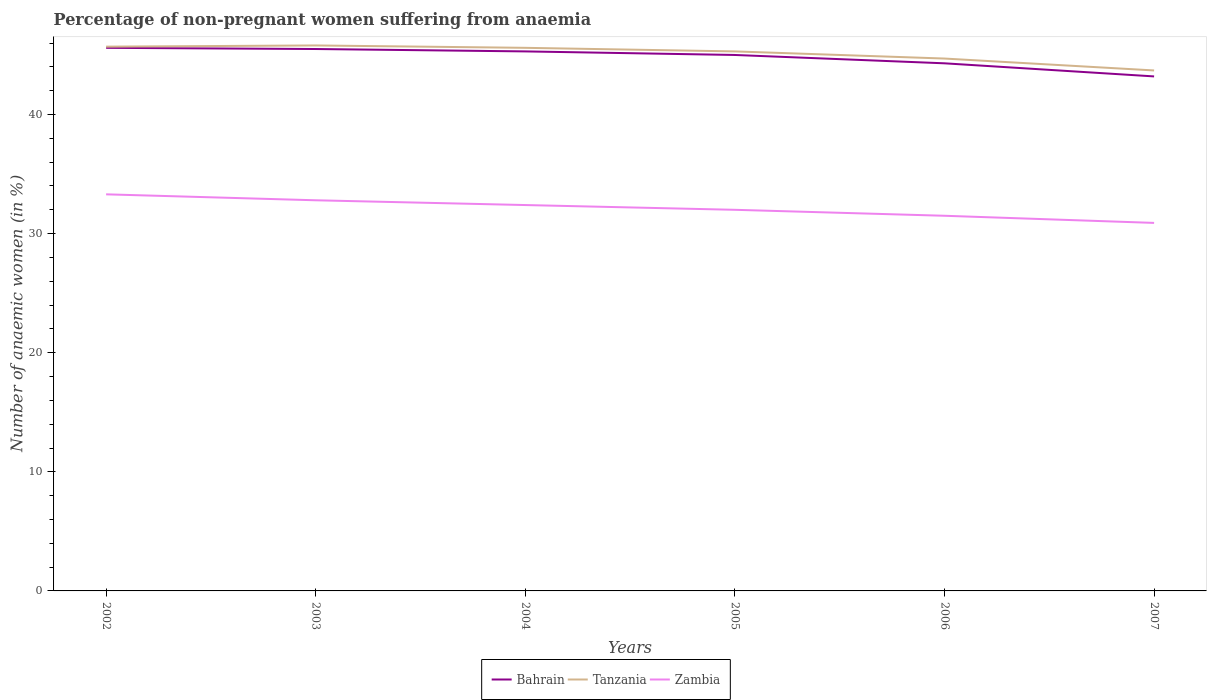How many different coloured lines are there?
Offer a terse response. 3. Does the line corresponding to Tanzania intersect with the line corresponding to Zambia?
Your response must be concise. No. Across all years, what is the maximum percentage of non-pregnant women suffering from anaemia in Bahrain?
Your response must be concise. 43.2. In which year was the percentage of non-pregnant women suffering from anaemia in Bahrain maximum?
Ensure brevity in your answer.  2007. What is the difference between the highest and the second highest percentage of non-pregnant women suffering from anaemia in Tanzania?
Your answer should be compact. 2.1. Is the percentage of non-pregnant women suffering from anaemia in Tanzania strictly greater than the percentage of non-pregnant women suffering from anaemia in Bahrain over the years?
Provide a succinct answer. No. Does the graph contain grids?
Make the answer very short. No. How are the legend labels stacked?
Ensure brevity in your answer.  Horizontal. What is the title of the graph?
Ensure brevity in your answer.  Percentage of non-pregnant women suffering from anaemia. What is the label or title of the X-axis?
Your answer should be very brief. Years. What is the label or title of the Y-axis?
Your answer should be compact. Number of anaemic women (in %). What is the Number of anaemic women (in %) of Bahrain in 2002?
Provide a succinct answer. 45.6. What is the Number of anaemic women (in %) in Tanzania in 2002?
Offer a very short reply. 45.7. What is the Number of anaemic women (in %) in Zambia in 2002?
Provide a short and direct response. 33.3. What is the Number of anaemic women (in %) of Bahrain in 2003?
Keep it short and to the point. 45.5. What is the Number of anaemic women (in %) of Tanzania in 2003?
Provide a succinct answer. 45.8. What is the Number of anaemic women (in %) of Zambia in 2003?
Your response must be concise. 32.8. What is the Number of anaemic women (in %) in Bahrain in 2004?
Your response must be concise. 45.3. What is the Number of anaemic women (in %) of Tanzania in 2004?
Keep it short and to the point. 45.6. What is the Number of anaemic women (in %) of Zambia in 2004?
Your answer should be very brief. 32.4. What is the Number of anaemic women (in %) of Bahrain in 2005?
Your response must be concise. 45. What is the Number of anaemic women (in %) of Tanzania in 2005?
Make the answer very short. 45.3. What is the Number of anaemic women (in %) in Bahrain in 2006?
Your response must be concise. 44.3. What is the Number of anaemic women (in %) of Tanzania in 2006?
Ensure brevity in your answer.  44.7. What is the Number of anaemic women (in %) of Zambia in 2006?
Your answer should be very brief. 31.5. What is the Number of anaemic women (in %) in Bahrain in 2007?
Give a very brief answer. 43.2. What is the Number of anaemic women (in %) in Tanzania in 2007?
Offer a terse response. 43.7. What is the Number of anaemic women (in %) in Zambia in 2007?
Make the answer very short. 30.9. Across all years, what is the maximum Number of anaemic women (in %) of Bahrain?
Keep it short and to the point. 45.6. Across all years, what is the maximum Number of anaemic women (in %) in Tanzania?
Your answer should be very brief. 45.8. Across all years, what is the maximum Number of anaemic women (in %) in Zambia?
Give a very brief answer. 33.3. Across all years, what is the minimum Number of anaemic women (in %) in Bahrain?
Your answer should be very brief. 43.2. Across all years, what is the minimum Number of anaemic women (in %) of Tanzania?
Your answer should be very brief. 43.7. Across all years, what is the minimum Number of anaemic women (in %) in Zambia?
Provide a succinct answer. 30.9. What is the total Number of anaemic women (in %) of Bahrain in the graph?
Keep it short and to the point. 268.9. What is the total Number of anaemic women (in %) of Tanzania in the graph?
Make the answer very short. 270.8. What is the total Number of anaemic women (in %) of Zambia in the graph?
Your response must be concise. 192.9. What is the difference between the Number of anaemic women (in %) in Zambia in 2002 and that in 2003?
Your answer should be very brief. 0.5. What is the difference between the Number of anaemic women (in %) in Bahrain in 2002 and that in 2004?
Offer a terse response. 0.3. What is the difference between the Number of anaemic women (in %) in Tanzania in 2002 and that in 2004?
Provide a short and direct response. 0.1. What is the difference between the Number of anaemic women (in %) of Zambia in 2002 and that in 2004?
Offer a terse response. 0.9. What is the difference between the Number of anaemic women (in %) of Bahrain in 2002 and that in 2005?
Your answer should be very brief. 0.6. What is the difference between the Number of anaemic women (in %) of Tanzania in 2002 and that in 2005?
Your answer should be very brief. 0.4. What is the difference between the Number of anaemic women (in %) in Bahrain in 2002 and that in 2007?
Provide a succinct answer. 2.4. What is the difference between the Number of anaemic women (in %) of Tanzania in 2002 and that in 2007?
Make the answer very short. 2. What is the difference between the Number of anaemic women (in %) of Bahrain in 2003 and that in 2004?
Make the answer very short. 0.2. What is the difference between the Number of anaemic women (in %) in Tanzania in 2003 and that in 2004?
Offer a terse response. 0.2. What is the difference between the Number of anaemic women (in %) of Zambia in 2003 and that in 2006?
Offer a terse response. 1.3. What is the difference between the Number of anaemic women (in %) in Tanzania in 2003 and that in 2007?
Your answer should be very brief. 2.1. What is the difference between the Number of anaemic women (in %) of Zambia in 2004 and that in 2005?
Keep it short and to the point. 0.4. What is the difference between the Number of anaemic women (in %) in Bahrain in 2004 and that in 2006?
Provide a succinct answer. 1. What is the difference between the Number of anaemic women (in %) of Tanzania in 2004 and that in 2006?
Provide a short and direct response. 0.9. What is the difference between the Number of anaemic women (in %) of Zambia in 2004 and that in 2006?
Your response must be concise. 0.9. What is the difference between the Number of anaemic women (in %) of Bahrain in 2004 and that in 2007?
Give a very brief answer. 2.1. What is the difference between the Number of anaemic women (in %) in Tanzania in 2004 and that in 2007?
Offer a terse response. 1.9. What is the difference between the Number of anaemic women (in %) in Bahrain in 2005 and that in 2006?
Provide a short and direct response. 0.7. What is the difference between the Number of anaemic women (in %) of Zambia in 2005 and that in 2006?
Make the answer very short. 0.5. What is the difference between the Number of anaemic women (in %) of Bahrain in 2002 and the Number of anaemic women (in %) of Tanzania in 2003?
Give a very brief answer. -0.2. What is the difference between the Number of anaemic women (in %) in Tanzania in 2002 and the Number of anaemic women (in %) in Zambia in 2003?
Give a very brief answer. 12.9. What is the difference between the Number of anaemic women (in %) in Bahrain in 2002 and the Number of anaemic women (in %) in Zambia in 2004?
Make the answer very short. 13.2. What is the difference between the Number of anaemic women (in %) of Bahrain in 2002 and the Number of anaemic women (in %) of Tanzania in 2005?
Provide a succinct answer. 0.3. What is the difference between the Number of anaemic women (in %) of Tanzania in 2002 and the Number of anaemic women (in %) of Zambia in 2005?
Your answer should be very brief. 13.7. What is the difference between the Number of anaemic women (in %) of Bahrain in 2002 and the Number of anaemic women (in %) of Tanzania in 2006?
Provide a short and direct response. 0.9. What is the difference between the Number of anaemic women (in %) of Bahrain in 2002 and the Number of anaemic women (in %) of Tanzania in 2007?
Give a very brief answer. 1.9. What is the difference between the Number of anaemic women (in %) of Tanzania in 2002 and the Number of anaemic women (in %) of Zambia in 2007?
Give a very brief answer. 14.8. What is the difference between the Number of anaemic women (in %) in Bahrain in 2003 and the Number of anaemic women (in %) in Tanzania in 2004?
Offer a terse response. -0.1. What is the difference between the Number of anaemic women (in %) in Bahrain in 2003 and the Number of anaemic women (in %) in Zambia in 2004?
Your answer should be very brief. 13.1. What is the difference between the Number of anaemic women (in %) of Bahrain in 2003 and the Number of anaemic women (in %) of Zambia in 2005?
Offer a terse response. 13.5. What is the difference between the Number of anaemic women (in %) of Tanzania in 2003 and the Number of anaemic women (in %) of Zambia in 2005?
Offer a very short reply. 13.8. What is the difference between the Number of anaemic women (in %) of Bahrain in 2003 and the Number of anaemic women (in %) of Tanzania in 2006?
Give a very brief answer. 0.8. What is the difference between the Number of anaemic women (in %) of Tanzania in 2003 and the Number of anaemic women (in %) of Zambia in 2006?
Make the answer very short. 14.3. What is the difference between the Number of anaemic women (in %) in Tanzania in 2003 and the Number of anaemic women (in %) in Zambia in 2007?
Offer a very short reply. 14.9. What is the difference between the Number of anaemic women (in %) of Bahrain in 2004 and the Number of anaemic women (in %) of Zambia in 2005?
Offer a very short reply. 13.3. What is the difference between the Number of anaemic women (in %) in Bahrain in 2004 and the Number of anaemic women (in %) in Tanzania in 2007?
Offer a very short reply. 1.6. What is the difference between the Number of anaemic women (in %) in Bahrain in 2004 and the Number of anaemic women (in %) in Zambia in 2007?
Ensure brevity in your answer.  14.4. What is the difference between the Number of anaemic women (in %) in Tanzania in 2004 and the Number of anaemic women (in %) in Zambia in 2007?
Make the answer very short. 14.7. What is the difference between the Number of anaemic women (in %) in Bahrain in 2005 and the Number of anaemic women (in %) in Zambia in 2006?
Offer a terse response. 13.5. What is the difference between the Number of anaemic women (in %) in Bahrain in 2005 and the Number of anaemic women (in %) in Tanzania in 2007?
Make the answer very short. 1.3. What is the difference between the Number of anaemic women (in %) of Bahrain in 2005 and the Number of anaemic women (in %) of Zambia in 2007?
Your response must be concise. 14.1. What is the difference between the Number of anaemic women (in %) of Tanzania in 2005 and the Number of anaemic women (in %) of Zambia in 2007?
Your answer should be compact. 14.4. What is the difference between the Number of anaemic women (in %) of Bahrain in 2006 and the Number of anaemic women (in %) of Tanzania in 2007?
Offer a very short reply. 0.6. What is the difference between the Number of anaemic women (in %) of Tanzania in 2006 and the Number of anaemic women (in %) of Zambia in 2007?
Give a very brief answer. 13.8. What is the average Number of anaemic women (in %) of Bahrain per year?
Provide a succinct answer. 44.82. What is the average Number of anaemic women (in %) in Tanzania per year?
Your answer should be compact. 45.13. What is the average Number of anaemic women (in %) of Zambia per year?
Your response must be concise. 32.15. In the year 2002, what is the difference between the Number of anaemic women (in %) in Bahrain and Number of anaemic women (in %) in Tanzania?
Your response must be concise. -0.1. In the year 2003, what is the difference between the Number of anaemic women (in %) in Bahrain and Number of anaemic women (in %) in Tanzania?
Keep it short and to the point. -0.3. In the year 2003, what is the difference between the Number of anaemic women (in %) of Tanzania and Number of anaemic women (in %) of Zambia?
Ensure brevity in your answer.  13. In the year 2004, what is the difference between the Number of anaemic women (in %) of Bahrain and Number of anaemic women (in %) of Tanzania?
Offer a very short reply. -0.3. In the year 2004, what is the difference between the Number of anaemic women (in %) in Tanzania and Number of anaemic women (in %) in Zambia?
Offer a very short reply. 13.2. In the year 2005, what is the difference between the Number of anaemic women (in %) in Bahrain and Number of anaemic women (in %) in Zambia?
Provide a short and direct response. 13. In the year 2006, what is the difference between the Number of anaemic women (in %) of Bahrain and Number of anaemic women (in %) of Tanzania?
Your answer should be very brief. -0.4. In the year 2007, what is the difference between the Number of anaemic women (in %) of Tanzania and Number of anaemic women (in %) of Zambia?
Your answer should be compact. 12.8. What is the ratio of the Number of anaemic women (in %) of Zambia in 2002 to that in 2003?
Your response must be concise. 1.02. What is the ratio of the Number of anaemic women (in %) in Bahrain in 2002 to that in 2004?
Give a very brief answer. 1.01. What is the ratio of the Number of anaemic women (in %) of Zambia in 2002 to that in 2004?
Ensure brevity in your answer.  1.03. What is the ratio of the Number of anaemic women (in %) of Bahrain in 2002 to that in 2005?
Your answer should be compact. 1.01. What is the ratio of the Number of anaemic women (in %) of Tanzania in 2002 to that in 2005?
Give a very brief answer. 1.01. What is the ratio of the Number of anaemic women (in %) of Zambia in 2002 to that in 2005?
Give a very brief answer. 1.04. What is the ratio of the Number of anaemic women (in %) of Bahrain in 2002 to that in 2006?
Your answer should be very brief. 1.03. What is the ratio of the Number of anaemic women (in %) of Tanzania in 2002 to that in 2006?
Make the answer very short. 1.02. What is the ratio of the Number of anaemic women (in %) of Zambia in 2002 to that in 2006?
Provide a short and direct response. 1.06. What is the ratio of the Number of anaemic women (in %) of Bahrain in 2002 to that in 2007?
Offer a terse response. 1.06. What is the ratio of the Number of anaemic women (in %) of Tanzania in 2002 to that in 2007?
Offer a terse response. 1.05. What is the ratio of the Number of anaemic women (in %) in Zambia in 2002 to that in 2007?
Your answer should be compact. 1.08. What is the ratio of the Number of anaemic women (in %) in Zambia in 2003 to that in 2004?
Give a very brief answer. 1.01. What is the ratio of the Number of anaemic women (in %) in Bahrain in 2003 to that in 2005?
Your answer should be compact. 1.01. What is the ratio of the Number of anaemic women (in %) in Tanzania in 2003 to that in 2005?
Offer a terse response. 1.01. What is the ratio of the Number of anaemic women (in %) in Bahrain in 2003 to that in 2006?
Provide a succinct answer. 1.03. What is the ratio of the Number of anaemic women (in %) of Tanzania in 2003 to that in 2006?
Keep it short and to the point. 1.02. What is the ratio of the Number of anaemic women (in %) in Zambia in 2003 to that in 2006?
Provide a short and direct response. 1.04. What is the ratio of the Number of anaemic women (in %) in Bahrain in 2003 to that in 2007?
Your response must be concise. 1.05. What is the ratio of the Number of anaemic women (in %) in Tanzania in 2003 to that in 2007?
Your response must be concise. 1.05. What is the ratio of the Number of anaemic women (in %) of Zambia in 2003 to that in 2007?
Your response must be concise. 1.06. What is the ratio of the Number of anaemic women (in %) in Bahrain in 2004 to that in 2005?
Make the answer very short. 1.01. What is the ratio of the Number of anaemic women (in %) in Tanzania in 2004 to that in 2005?
Your answer should be very brief. 1.01. What is the ratio of the Number of anaemic women (in %) in Zambia in 2004 to that in 2005?
Give a very brief answer. 1.01. What is the ratio of the Number of anaemic women (in %) of Bahrain in 2004 to that in 2006?
Offer a very short reply. 1.02. What is the ratio of the Number of anaemic women (in %) in Tanzania in 2004 to that in 2006?
Make the answer very short. 1.02. What is the ratio of the Number of anaemic women (in %) of Zambia in 2004 to that in 2006?
Keep it short and to the point. 1.03. What is the ratio of the Number of anaemic women (in %) of Bahrain in 2004 to that in 2007?
Your answer should be very brief. 1.05. What is the ratio of the Number of anaemic women (in %) of Tanzania in 2004 to that in 2007?
Give a very brief answer. 1.04. What is the ratio of the Number of anaemic women (in %) in Zambia in 2004 to that in 2007?
Your answer should be very brief. 1.05. What is the ratio of the Number of anaemic women (in %) of Bahrain in 2005 to that in 2006?
Provide a short and direct response. 1.02. What is the ratio of the Number of anaemic women (in %) of Tanzania in 2005 to that in 2006?
Your answer should be compact. 1.01. What is the ratio of the Number of anaemic women (in %) in Zambia in 2005 to that in 2006?
Keep it short and to the point. 1.02. What is the ratio of the Number of anaemic women (in %) of Bahrain in 2005 to that in 2007?
Your answer should be compact. 1.04. What is the ratio of the Number of anaemic women (in %) in Tanzania in 2005 to that in 2007?
Your answer should be very brief. 1.04. What is the ratio of the Number of anaemic women (in %) of Zambia in 2005 to that in 2007?
Offer a terse response. 1.04. What is the ratio of the Number of anaemic women (in %) of Bahrain in 2006 to that in 2007?
Keep it short and to the point. 1.03. What is the ratio of the Number of anaemic women (in %) of Tanzania in 2006 to that in 2007?
Provide a succinct answer. 1.02. What is the ratio of the Number of anaemic women (in %) of Zambia in 2006 to that in 2007?
Your answer should be compact. 1.02. What is the difference between the highest and the second highest Number of anaemic women (in %) of Tanzania?
Offer a very short reply. 0.1. What is the difference between the highest and the lowest Number of anaemic women (in %) in Zambia?
Offer a very short reply. 2.4. 